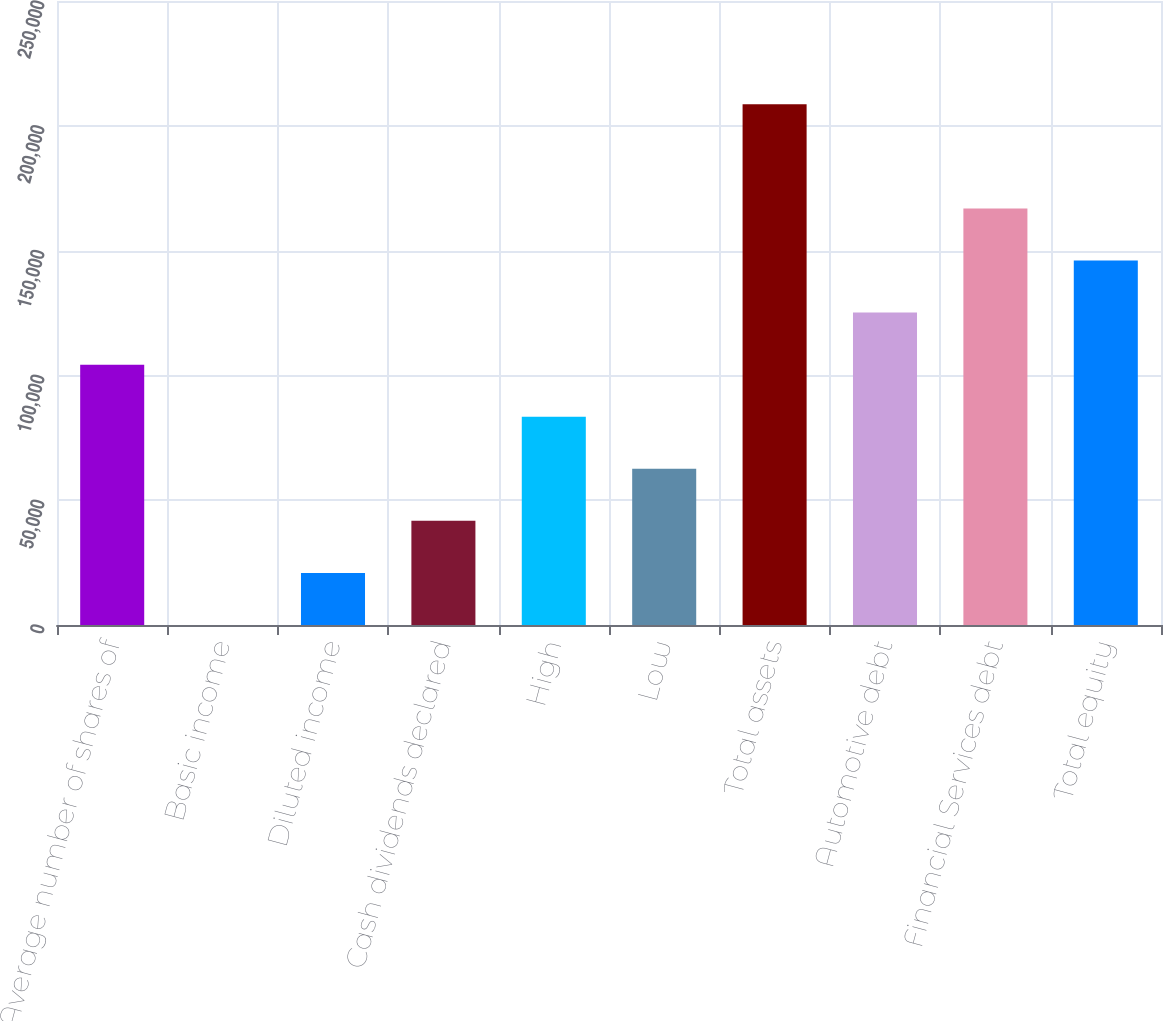<chart> <loc_0><loc_0><loc_500><loc_500><bar_chart><fcel>Average number of shares of<fcel>Basic income<fcel>Diluted income<fcel>Cash dividends declared<fcel>High<fcel>Low<fcel>Total assets<fcel>Automotive debt<fcel>Financial Services debt<fcel>Total equity<nl><fcel>104308<fcel>0.31<fcel>20861.8<fcel>41723.2<fcel>83446.2<fcel>62584.7<fcel>208615<fcel>125169<fcel>166892<fcel>146031<nl></chart> 